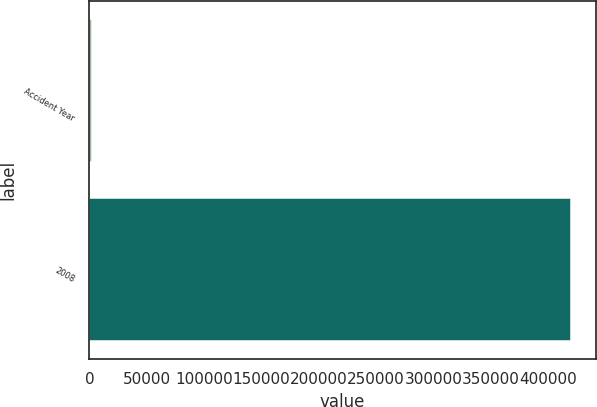Convert chart. <chart><loc_0><loc_0><loc_500><loc_500><bar_chart><fcel>Accident Year<fcel>2008<nl><fcel>2015<fcel>420553<nl></chart> 